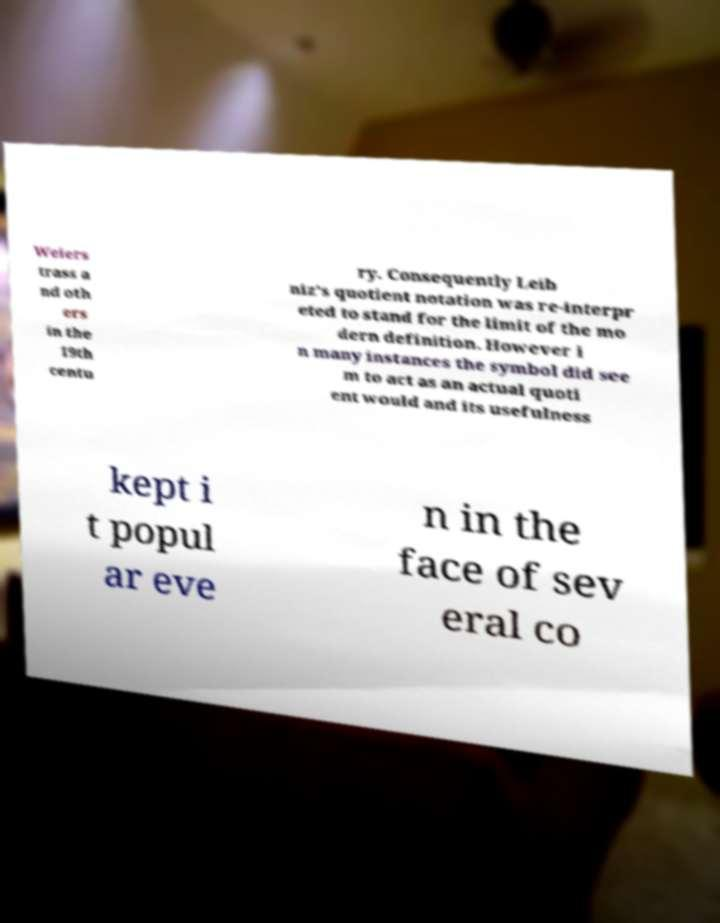What messages or text are displayed in this image? I need them in a readable, typed format. Weiers trass a nd oth ers in the 19th centu ry. Consequently Leib niz's quotient notation was re-interpr eted to stand for the limit of the mo dern definition. However i n many instances the symbol did see m to act as an actual quoti ent would and its usefulness kept i t popul ar eve n in the face of sev eral co 